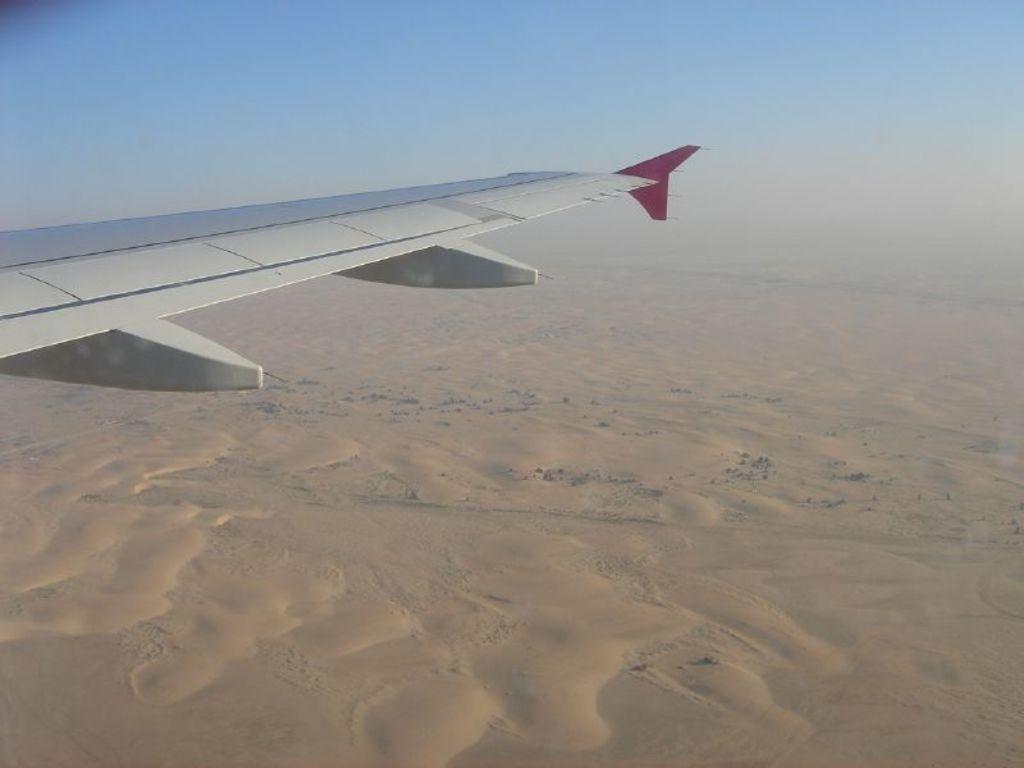In one or two sentences, can you explain what this image depicts? In the image we can see there is a side wing of an aeroplane. On the ground there is sand and there is a clear sky. 